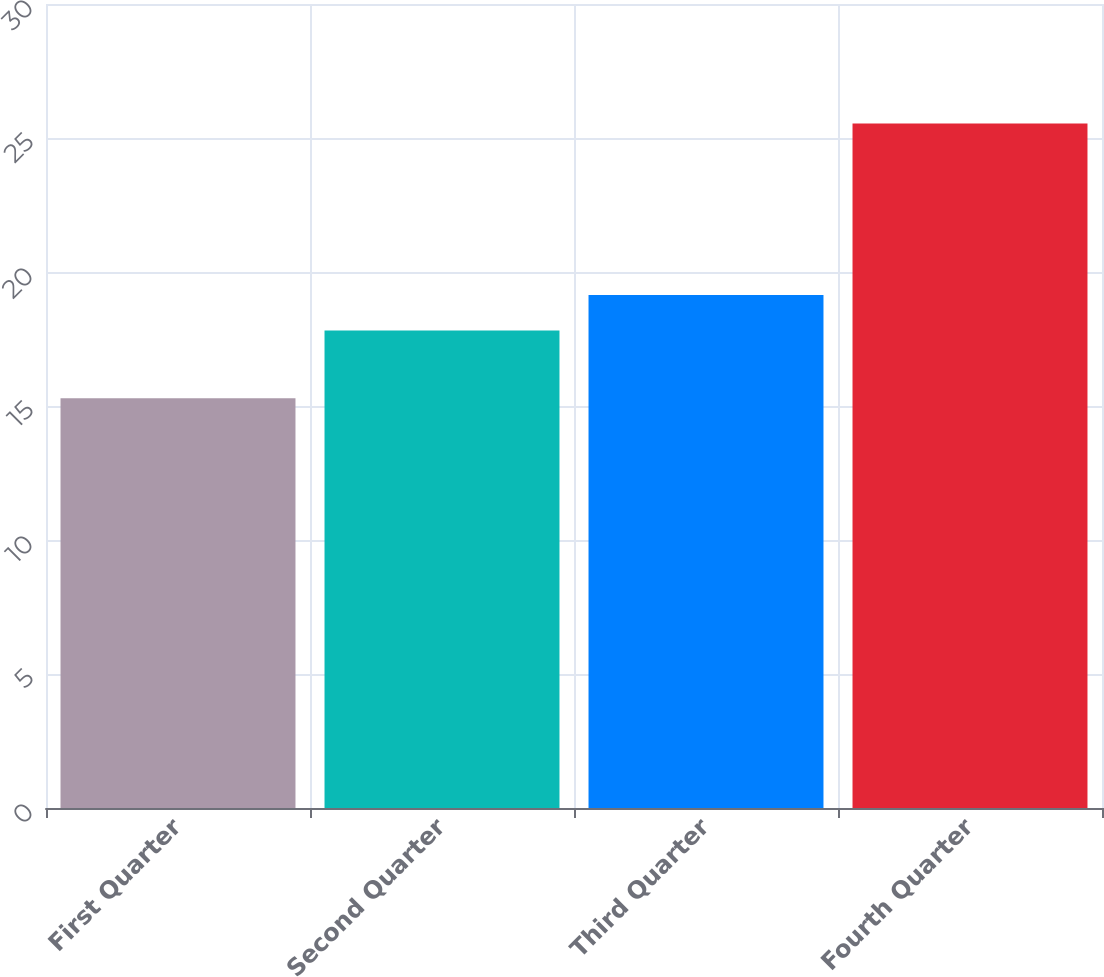Convert chart to OTSL. <chart><loc_0><loc_0><loc_500><loc_500><bar_chart><fcel>First Quarter<fcel>Second Quarter<fcel>Third Quarter<fcel>Fourth Quarter<nl><fcel>15.29<fcel>17.82<fcel>19.14<fcel>25.54<nl></chart> 